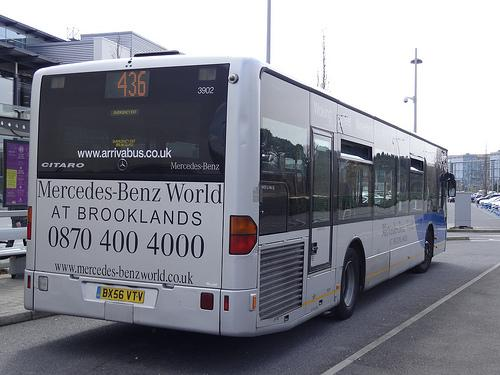What type of advertisement is on the back of the bus? Also, mention the company's name. There is a promotional advertisement for Mercedes-Benz, and the company's name is Citaro. Explain the overall sentiment or mood of the image. The image has a neutral sentiment, as it portrays a stationary white bus in a parking lot with no specific mood or emotion. Provide a brief description of the bus's license plate and the colors involved. The license plate is yellow with black lettering, and the number is BX56 VTV. Determine the bus's route number and the color of the number. The bus's route number is 436, and it is in orange color. Identify the primary object in the image and the color of the object. The primary object is a white bus with various features and elements, such as numbers, texts, and advertisement. What is written on the rear right side of the bus, and what color is the font? The word "Brooklands" is written on the rear right side of the bus, and the font is black. Describe the setting where the bus is located. The bus is in a parking lot with grey pavement, standing still. What is the make and model of the bus? The bus is a Mercedes-Benz and the model is Citaro. Count the number of open windows on the bus. There are two open windows on the bus. How many wheels are visible on the bus, and what colors are they? Four wheels are visible on the bus, and they are black with silver rims. 